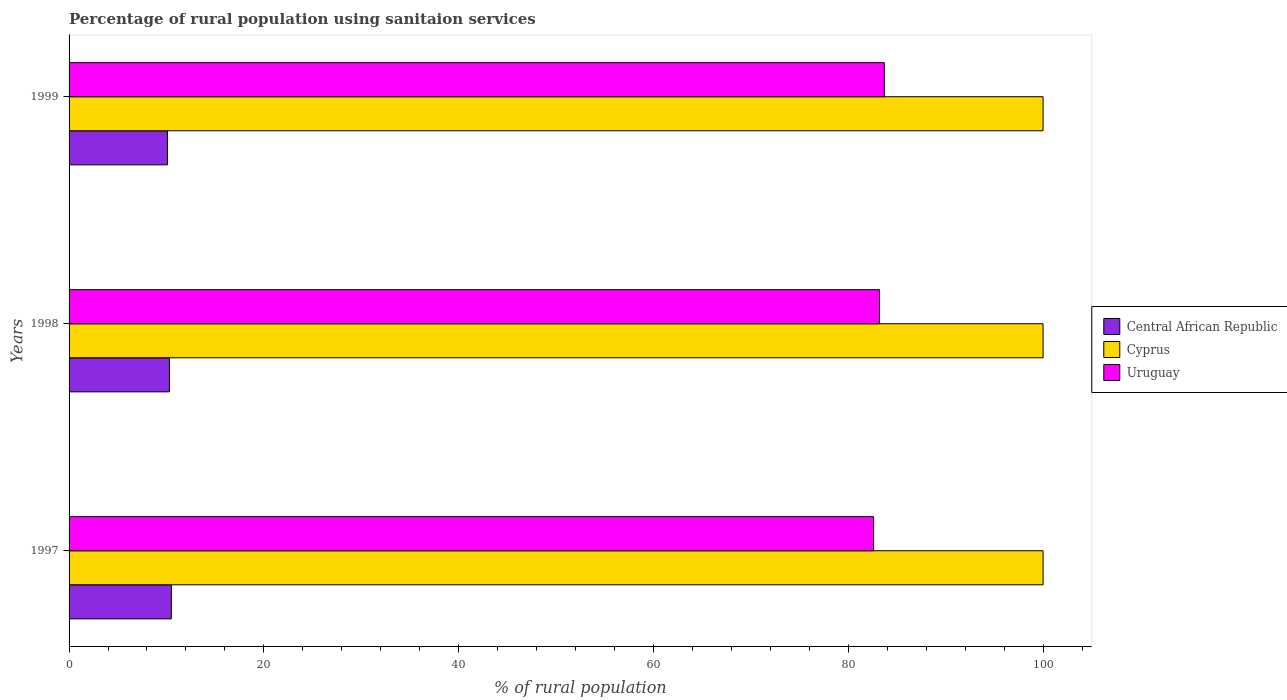Are the number of bars per tick equal to the number of legend labels?
Offer a terse response. Yes. Are the number of bars on each tick of the Y-axis equal?
Provide a succinct answer. Yes. How many bars are there on the 2nd tick from the top?
Your answer should be compact. 3. How many bars are there on the 2nd tick from the bottom?
Offer a terse response. 3. What is the label of the 3rd group of bars from the top?
Your answer should be very brief. 1997. Across all years, what is the maximum percentage of rural population using sanitaion services in Uruguay?
Offer a terse response. 83.7. Across all years, what is the minimum percentage of rural population using sanitaion services in Cyprus?
Your answer should be very brief. 100. In which year was the percentage of rural population using sanitaion services in Cyprus minimum?
Offer a terse response. 1997. What is the total percentage of rural population using sanitaion services in Central African Republic in the graph?
Offer a terse response. 30.9. What is the difference between the percentage of rural population using sanitaion services in Central African Republic in 1997 and that in 1998?
Your answer should be compact. 0.2. What is the difference between the percentage of rural population using sanitaion services in Cyprus in 1997 and the percentage of rural population using sanitaion services in Uruguay in 1999?
Ensure brevity in your answer.  16.3. What is the average percentage of rural population using sanitaion services in Central African Republic per year?
Offer a terse response. 10.3. In the year 1999, what is the difference between the percentage of rural population using sanitaion services in Cyprus and percentage of rural population using sanitaion services in Uruguay?
Your answer should be very brief. 16.3. What is the ratio of the percentage of rural population using sanitaion services in Central African Republic in 1998 to that in 1999?
Keep it short and to the point. 1.02. Is the percentage of rural population using sanitaion services in Uruguay in 1998 less than that in 1999?
Give a very brief answer. Yes. Is the difference between the percentage of rural population using sanitaion services in Cyprus in 1997 and 1998 greater than the difference between the percentage of rural population using sanitaion services in Uruguay in 1997 and 1998?
Your answer should be very brief. Yes. What is the difference between the highest and the second highest percentage of rural population using sanitaion services in Uruguay?
Make the answer very short. 0.5. What is the difference between the highest and the lowest percentage of rural population using sanitaion services in Uruguay?
Provide a succinct answer. 1.1. What does the 1st bar from the top in 1999 represents?
Offer a terse response. Uruguay. What does the 3rd bar from the bottom in 1999 represents?
Your answer should be very brief. Uruguay. How many years are there in the graph?
Provide a succinct answer. 3. Where does the legend appear in the graph?
Provide a succinct answer. Center right. How many legend labels are there?
Your answer should be compact. 3. How are the legend labels stacked?
Your answer should be compact. Vertical. What is the title of the graph?
Provide a succinct answer. Percentage of rural population using sanitaion services. Does "Cameroon" appear as one of the legend labels in the graph?
Your answer should be compact. No. What is the label or title of the X-axis?
Ensure brevity in your answer.  % of rural population. What is the % of rural population in Central African Republic in 1997?
Provide a succinct answer. 10.5. What is the % of rural population in Cyprus in 1997?
Your answer should be compact. 100. What is the % of rural population of Uruguay in 1997?
Your response must be concise. 82.6. What is the % of rural population in Cyprus in 1998?
Your response must be concise. 100. What is the % of rural population of Uruguay in 1998?
Make the answer very short. 83.2. What is the % of rural population in Central African Republic in 1999?
Keep it short and to the point. 10.1. What is the % of rural population in Uruguay in 1999?
Keep it short and to the point. 83.7. Across all years, what is the maximum % of rural population of Central African Republic?
Your answer should be compact. 10.5. Across all years, what is the maximum % of rural population of Cyprus?
Give a very brief answer. 100. Across all years, what is the maximum % of rural population in Uruguay?
Provide a short and direct response. 83.7. Across all years, what is the minimum % of rural population in Cyprus?
Give a very brief answer. 100. Across all years, what is the minimum % of rural population of Uruguay?
Offer a very short reply. 82.6. What is the total % of rural population in Central African Republic in the graph?
Give a very brief answer. 30.9. What is the total % of rural population of Cyprus in the graph?
Your answer should be compact. 300. What is the total % of rural population in Uruguay in the graph?
Offer a terse response. 249.5. What is the difference between the % of rural population in Cyprus in 1997 and that in 1998?
Ensure brevity in your answer.  0. What is the difference between the % of rural population in Central African Republic in 1998 and that in 1999?
Make the answer very short. 0.2. What is the difference between the % of rural population of Cyprus in 1998 and that in 1999?
Keep it short and to the point. 0. What is the difference between the % of rural population in Uruguay in 1998 and that in 1999?
Keep it short and to the point. -0.5. What is the difference between the % of rural population in Central African Republic in 1997 and the % of rural population in Cyprus in 1998?
Your answer should be very brief. -89.5. What is the difference between the % of rural population of Central African Republic in 1997 and the % of rural population of Uruguay in 1998?
Provide a short and direct response. -72.7. What is the difference between the % of rural population of Cyprus in 1997 and the % of rural population of Uruguay in 1998?
Give a very brief answer. 16.8. What is the difference between the % of rural population in Central African Republic in 1997 and the % of rural population in Cyprus in 1999?
Your answer should be compact. -89.5. What is the difference between the % of rural population in Central African Republic in 1997 and the % of rural population in Uruguay in 1999?
Offer a terse response. -73.2. What is the difference between the % of rural population in Cyprus in 1997 and the % of rural population in Uruguay in 1999?
Make the answer very short. 16.3. What is the difference between the % of rural population in Central African Republic in 1998 and the % of rural population in Cyprus in 1999?
Your answer should be compact. -89.7. What is the difference between the % of rural population in Central African Republic in 1998 and the % of rural population in Uruguay in 1999?
Make the answer very short. -73.4. What is the difference between the % of rural population of Cyprus in 1998 and the % of rural population of Uruguay in 1999?
Keep it short and to the point. 16.3. What is the average % of rural population of Cyprus per year?
Provide a short and direct response. 100. What is the average % of rural population of Uruguay per year?
Provide a short and direct response. 83.17. In the year 1997, what is the difference between the % of rural population of Central African Republic and % of rural population of Cyprus?
Provide a short and direct response. -89.5. In the year 1997, what is the difference between the % of rural population of Central African Republic and % of rural population of Uruguay?
Offer a very short reply. -72.1. In the year 1998, what is the difference between the % of rural population of Central African Republic and % of rural population of Cyprus?
Your answer should be compact. -89.7. In the year 1998, what is the difference between the % of rural population in Central African Republic and % of rural population in Uruguay?
Your answer should be very brief. -72.9. In the year 1998, what is the difference between the % of rural population in Cyprus and % of rural population in Uruguay?
Provide a short and direct response. 16.8. In the year 1999, what is the difference between the % of rural population in Central African Republic and % of rural population in Cyprus?
Provide a succinct answer. -89.9. In the year 1999, what is the difference between the % of rural population of Central African Republic and % of rural population of Uruguay?
Give a very brief answer. -73.6. What is the ratio of the % of rural population in Central African Republic in 1997 to that in 1998?
Offer a terse response. 1.02. What is the ratio of the % of rural population in Central African Republic in 1997 to that in 1999?
Your answer should be very brief. 1.04. What is the ratio of the % of rural population of Cyprus in 1997 to that in 1999?
Your answer should be very brief. 1. What is the ratio of the % of rural population in Uruguay in 1997 to that in 1999?
Keep it short and to the point. 0.99. What is the ratio of the % of rural population in Central African Republic in 1998 to that in 1999?
Ensure brevity in your answer.  1.02. What is the difference between the highest and the lowest % of rural population in Central African Republic?
Your answer should be very brief. 0.4. What is the difference between the highest and the lowest % of rural population of Cyprus?
Provide a short and direct response. 0. What is the difference between the highest and the lowest % of rural population of Uruguay?
Your answer should be very brief. 1.1. 